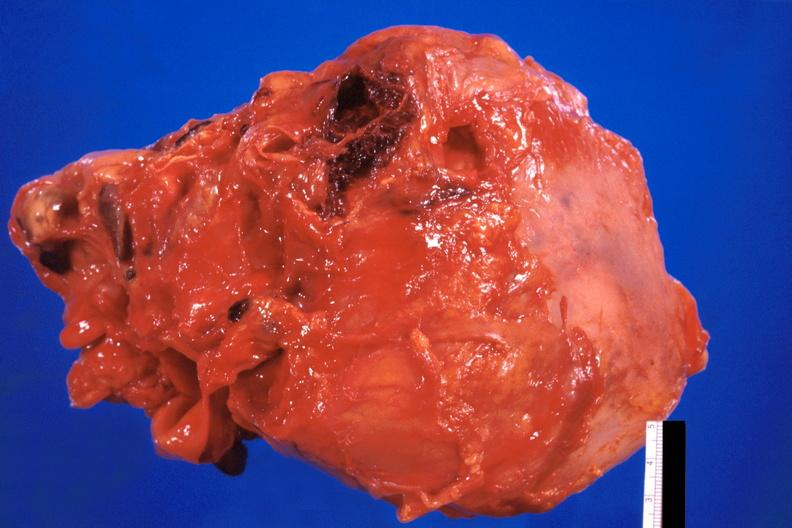does this image show pericarditis, secondary to mediastanitis from pseudomonas and enterobacter 14 days post op?
Answer the question using a single word or phrase. Yes 